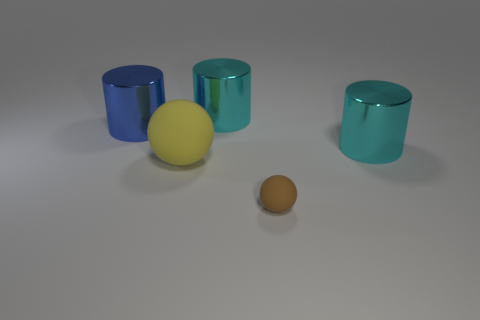Are there any other things that have the same size as the brown matte object?
Provide a succinct answer. No. What number of other things are there of the same size as the blue cylinder?
Keep it short and to the point. 3. There is a matte sphere on the left side of the matte ball in front of the yellow sphere; what is its color?
Your answer should be very brief. Yellow. What number of other objects are the same shape as the tiny matte thing?
Keep it short and to the point. 1. Is there a gray thing made of the same material as the yellow ball?
Keep it short and to the point. No. There is a ball that is the same size as the blue cylinder; what is it made of?
Give a very brief answer. Rubber. What is the color of the rubber sphere to the right of the large metal thing that is behind the cylinder left of the yellow sphere?
Provide a short and direct response. Brown. There is a large object that is to the right of the small brown object; is its shape the same as the cyan object to the left of the brown matte object?
Offer a terse response. Yes. How many large purple things are there?
Keep it short and to the point. 0. What is the color of the matte sphere that is the same size as the blue shiny cylinder?
Ensure brevity in your answer.  Yellow. 